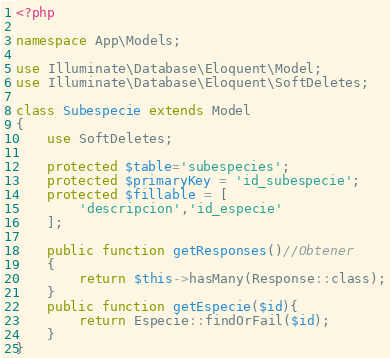<code> <loc_0><loc_0><loc_500><loc_500><_PHP_><?php

namespace App\Models;

use Illuminate\Database\Eloquent\Model;
use Illuminate\Database\Eloquent\SoftDeletes;

class Subespecie extends Model
{
    use SoftDeletes;

    protected $table='subespecies';
    protected $primaryKey = 'id_subespecie';
    protected $fillable = [
        'descripcion','id_especie'
    ];

    public function getResponses()//Obtener
    {
        return $this->hasMany(Response::class);
    }
    public function getEspecie($id){
        return Especie::findOrFail($id);
    }
}
</code> 